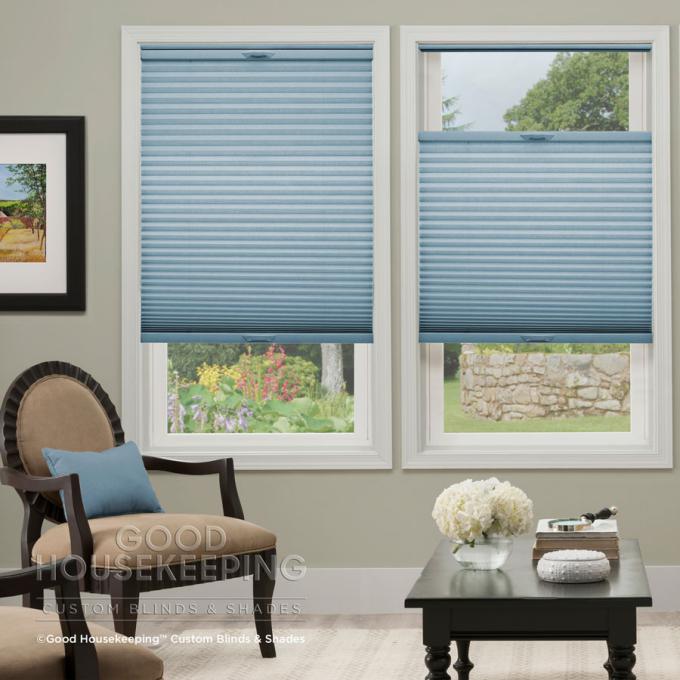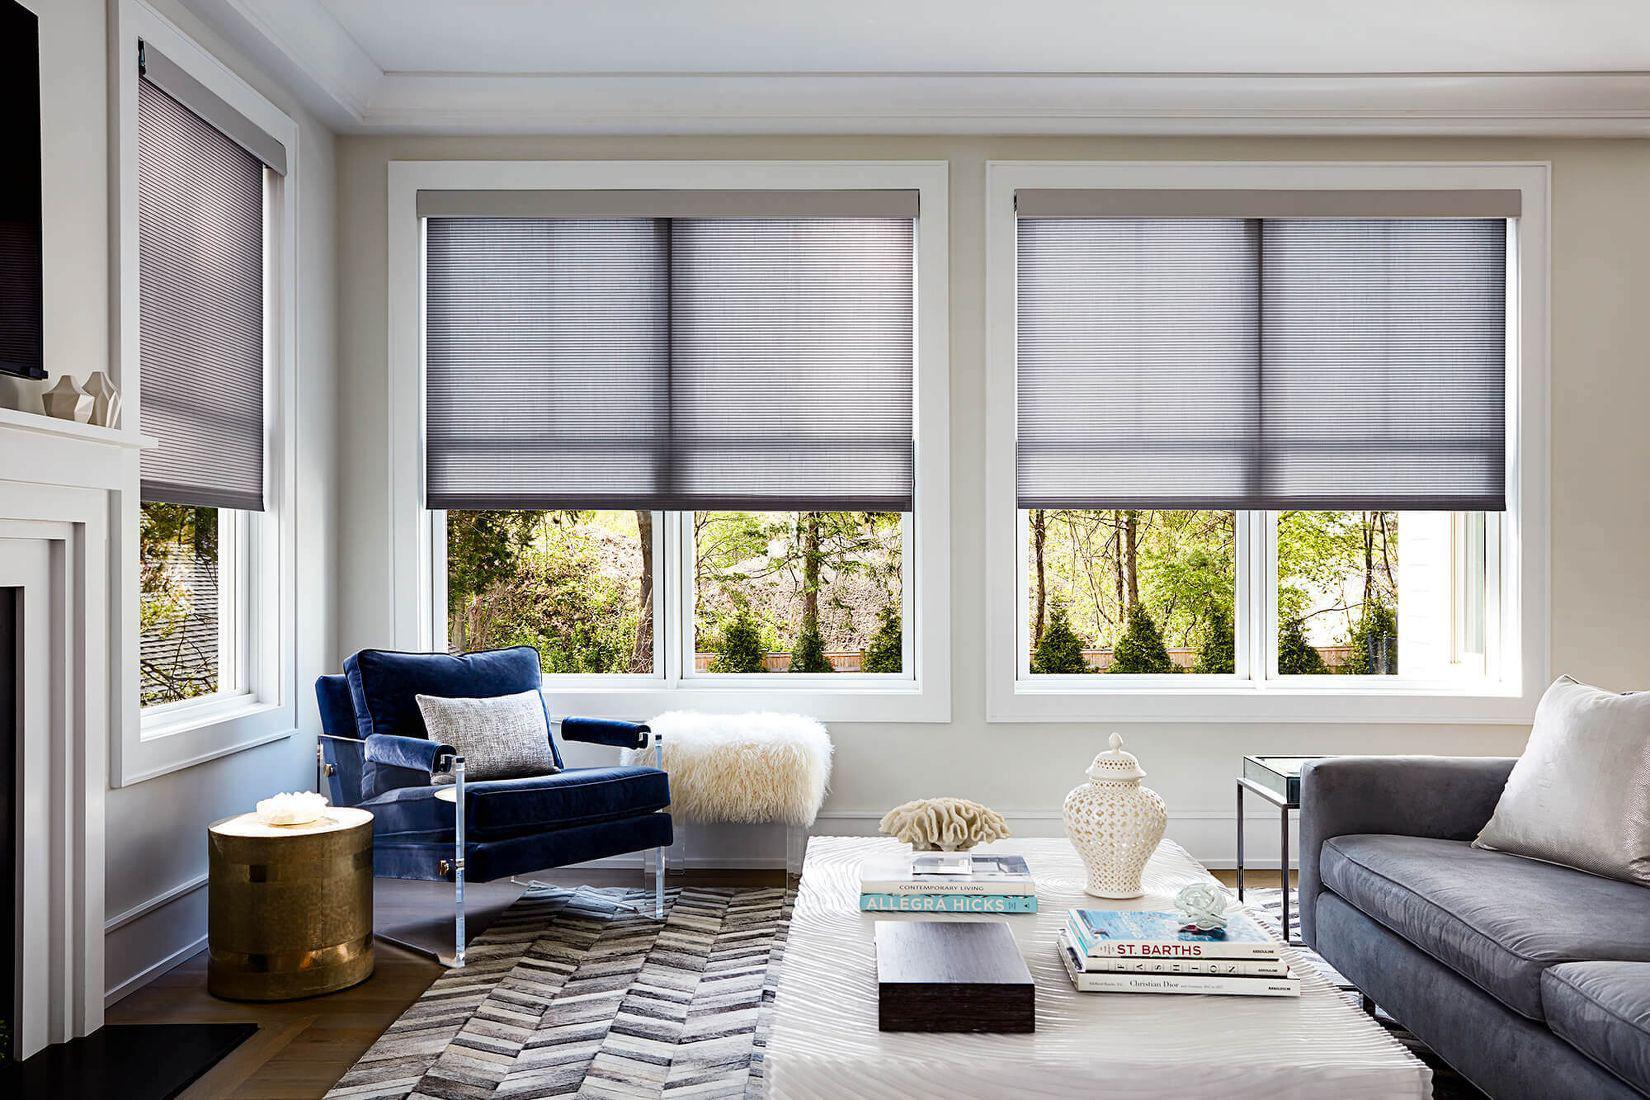The first image is the image on the left, the second image is the image on the right. Assess this claim about the two images: "There are five to six shades.". Correct or not? Answer yes or no. Yes. The first image is the image on the left, the second image is the image on the right. Examine the images to the left and right. Is the description "There are the same number of windows in both images." accurate? Answer yes or no. Yes. 